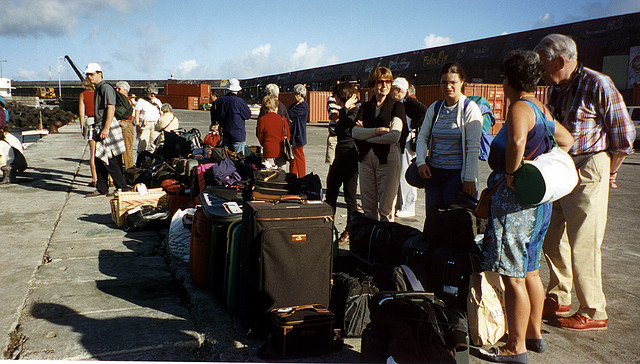<image>Is the sun on the left or right side of this picture? I am not sure if the sun is on the left or right side of the picture. Is the sun on the left or right side of this picture? The sun is on the right side of the picture. 